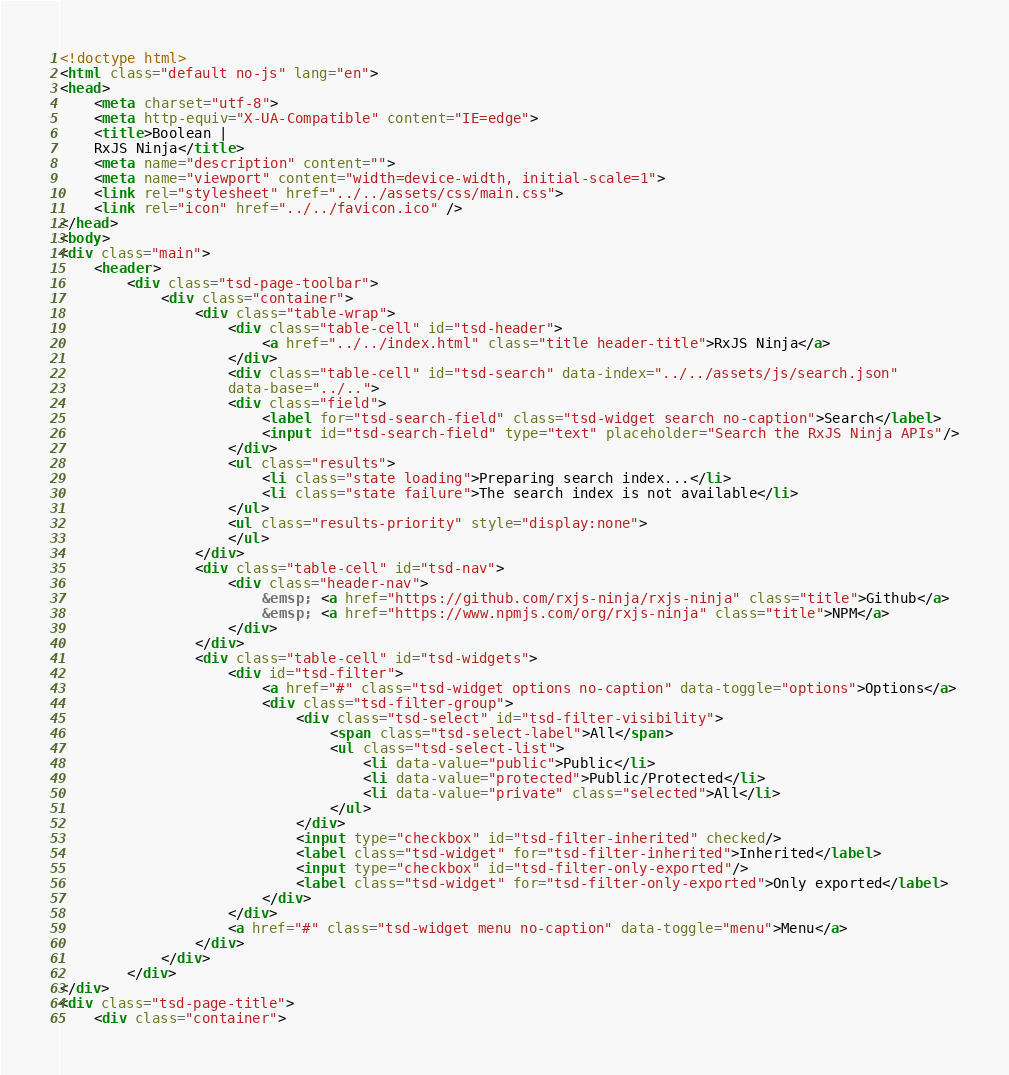Convert code to text. <code><loc_0><loc_0><loc_500><loc_500><_HTML_><!doctype html>
<html class="default no-js" lang="en">
<head>
	<meta charset="utf-8">
	<meta http-equiv="X-UA-Compatible" content="IE=edge">
	<title>Boolean |
	RxJS Ninja</title>
	<meta name="description" content="">
	<meta name="viewport" content="width=device-width, initial-scale=1">
	<link rel="stylesheet" href="../../assets/css/main.css">
	<link rel="icon" href="../../favicon.ico" />
</head>
<body>
<div class="main">
	<header>
		<div class="tsd-page-toolbar">
			<div class="container">
				<div class="table-wrap">
					<div class="table-cell" id="tsd-header">
						<a href="../../index.html" class="title header-title">RxJS Ninja</a>
					</div>
					<div class="table-cell" id="tsd-search" data-index="../../assets/js/search.json"
					data-base="../..">
					<div class="field">
						<label for="tsd-search-field" class="tsd-widget search no-caption">Search</label>
						<input id="tsd-search-field" type="text" placeholder="Search the RxJS Ninja APIs"/>
					</div>
					<ul class="results">
						<li class="state loading">Preparing search index...</li>
						<li class="state failure">The search index is not available</li>
					</ul>
					<ul class="results-priority" style="display:none">
					</ul>
				</div>
				<div class="table-cell" id="tsd-nav">
					<div class="header-nav">
						&emsp; <a href="https://github.com/rxjs-ninja/rxjs-ninja" class="title">Github</a>
						&emsp; <a href="https://www.npmjs.com/org/rxjs-ninja" class="title">NPM</a>
					</div>
				</div>
				<div class="table-cell" id="tsd-widgets">
					<div id="tsd-filter">
						<a href="#" class="tsd-widget options no-caption" data-toggle="options">Options</a>
						<div class="tsd-filter-group">
							<div class="tsd-select" id="tsd-filter-visibility">
								<span class="tsd-select-label">All</span>
								<ul class="tsd-select-list">
									<li data-value="public">Public</li>
									<li data-value="protected">Public/Protected</li>
									<li data-value="private" class="selected">All</li>
								</ul>
							</div>
							<input type="checkbox" id="tsd-filter-inherited" checked/>
							<label class="tsd-widget" for="tsd-filter-inherited">Inherited</label>
							<input type="checkbox" id="tsd-filter-only-exported"/>
							<label class="tsd-widget" for="tsd-filter-only-exported">Only exported</label>
						</div>
					</div>
					<a href="#" class="tsd-widget menu no-caption" data-toggle="menu">Menu</a>
				</div>
			</div>
		</div>
</div>
<div class="tsd-page-title">
	<div class="container"></code> 